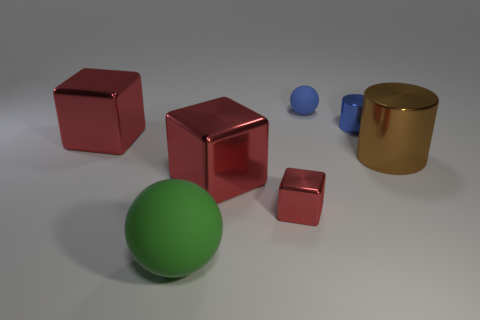Is the number of brown metal cylinders that are left of the large brown thing less than the number of tiny brown matte balls?
Ensure brevity in your answer.  No. What color is the metallic cube to the left of the matte object in front of the tiny object left of the blue ball?
Your answer should be very brief. Red. What number of metal things are either small purple cylinders or large objects?
Ensure brevity in your answer.  3. Does the blue metal cylinder have the same size as the blue ball?
Give a very brief answer. Yes. Is the number of large green balls behind the big cylinder less than the number of large cylinders that are right of the green sphere?
Your response must be concise. Yes. Is there anything else that has the same size as the blue ball?
Your answer should be compact. Yes. The blue matte ball has what size?
Ensure brevity in your answer.  Small. How many small objects are yellow things or shiny things?
Your answer should be very brief. 2. There is a green rubber object; does it have the same size as the sphere that is behind the small blue metallic cylinder?
Provide a succinct answer. No. What number of big red shiny objects are there?
Make the answer very short. 2. 